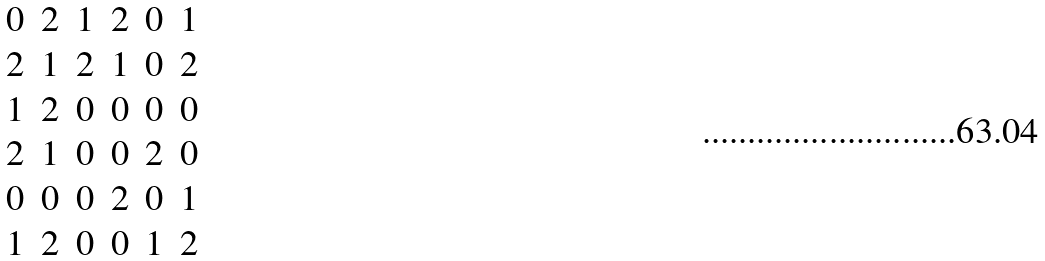Convert formula to latex. <formula><loc_0><loc_0><loc_500><loc_500>\begin{matrix} 0 & 2 & 1 & 2 & 0 & 1 \\ 2 & 1 & 2 & 1 & 0 & 2 \\ 1 & 2 & 0 & 0 & 0 & 0 \\ 2 & 1 & 0 & 0 & 2 & 0 \\ 0 & 0 & 0 & 2 & 0 & 1 \\ 1 & 2 & 0 & 0 & 1 & 2 \end{matrix}</formula> 